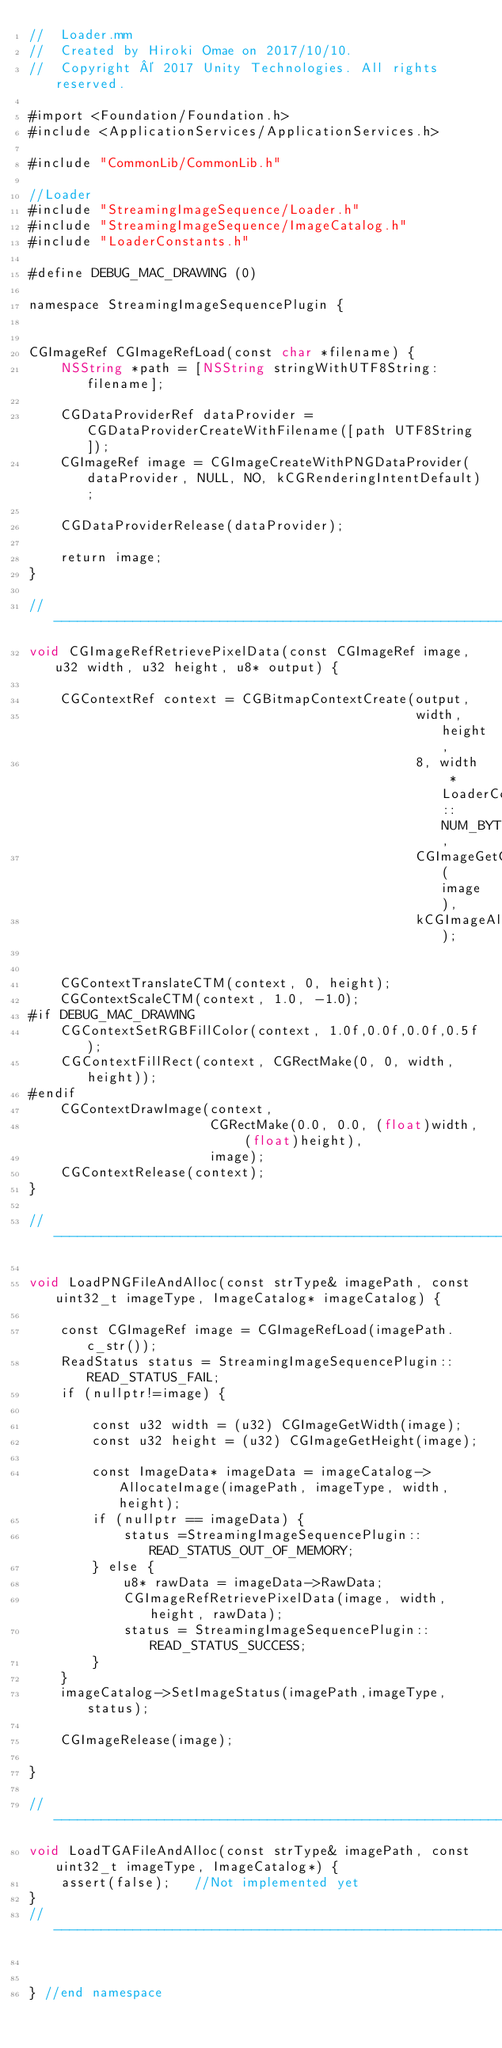<code> <loc_0><loc_0><loc_500><loc_500><_ObjectiveC_>//  Loader.mm
//  Created by Hiroki Omae on 2017/10/10.
//  Copyright © 2017 Unity Technologies. All rights reserved.

#import <Foundation/Foundation.h>
#include <ApplicationServices/ApplicationServices.h>

#include "CommonLib/CommonLib.h"

//Loader
#include "StreamingImageSequence/Loader.h"
#include "StreamingImageSequence/ImageCatalog.h"
#include "LoaderConstants.h"

#define DEBUG_MAC_DRAWING (0)

namespace StreamingImageSequencePlugin {


CGImageRef CGImageRefLoad(const char *filename) {
    NSString *path = [NSString stringWithUTF8String:filename];
    
    CGDataProviderRef dataProvider = CGDataProviderCreateWithFilename([path UTF8String]);
    CGImageRef image = CGImageCreateWithPNGDataProvider(dataProvider, NULL, NO, kCGRenderingIntentDefault);

    CGDataProviderRelease(dataProvider);
    
    return image;
}

//----------------------------------------------------------------------------------------------------------------------
void CGImageRefRetrievePixelData(const CGImageRef image, u32 width, u32 height, u8* output) {

    CGContextRef context = CGBitmapContextCreate(output,
                                                 width, height,
                                                 8, width * LoaderConstants::NUM_BYTES_PER_TEXEL,
                                                 CGImageGetColorSpace(image),
                                                 kCGImageAlphaPremultipliedLast);

    
    CGContextTranslateCTM(context, 0, height);
    CGContextScaleCTM(context, 1.0, -1.0);
#if DEBUG_MAC_DRAWING
    CGContextSetRGBFillColor(context, 1.0f,0.0f,0.0f,0.5f);
    CGContextFillRect(context, CGRectMake(0, 0, width, height));
#endif
    CGContextDrawImage(context,
                       CGRectMake(0.0, 0.0, (float)width, (float)height),
                       image);
    CGContextRelease(context);
}

//----------------------------------------------------------------------------------------------------------------------

void LoadPNGFileAndAlloc(const strType& imagePath, const uint32_t imageType, ImageCatalog* imageCatalog) {
        
    const CGImageRef image = CGImageRefLoad(imagePath.c_str());
    ReadStatus status = StreamingImageSequencePlugin::READ_STATUS_FAIL;
    if (nullptr!=image) {

        const u32 width = (u32) CGImageGetWidth(image);
        const u32 height = (u32) CGImageGetHeight(image);
        
        const ImageData* imageData = imageCatalog->AllocateImage(imagePath, imageType, width, height);
        if (nullptr == imageData) {
            status =StreamingImageSequencePlugin::READ_STATUS_OUT_OF_MEMORY;
        } else {
            u8* rawData = imageData->RawData;
            CGImageRefRetrievePixelData(image, width, height, rawData);
            status = StreamingImageSequencePlugin::READ_STATUS_SUCCESS;
        }
    }
    imageCatalog->SetImageStatus(imagePath,imageType, status);

    CGImageRelease(image);
    
}

//----------------------------------------------------------------------------------------------------------------------
void LoadTGAFileAndAlloc(const strType& imagePath, const uint32_t imageType, ImageCatalog*) {
    assert(false);   //Not implemented yet
}
//----------------------------------------------------------------------------------------------------------------------


} //end namespace
</code> 